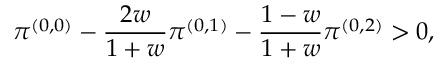Convert formula to latex. <formula><loc_0><loc_0><loc_500><loc_500>\pi ^ { ( 0 , 0 ) } - \frac { 2 w } { 1 + w } \pi ^ { ( 0 , 1 ) } - \frac { 1 - w } { 1 + w } \pi ^ { ( 0 , 2 ) } > 0 ,</formula> 